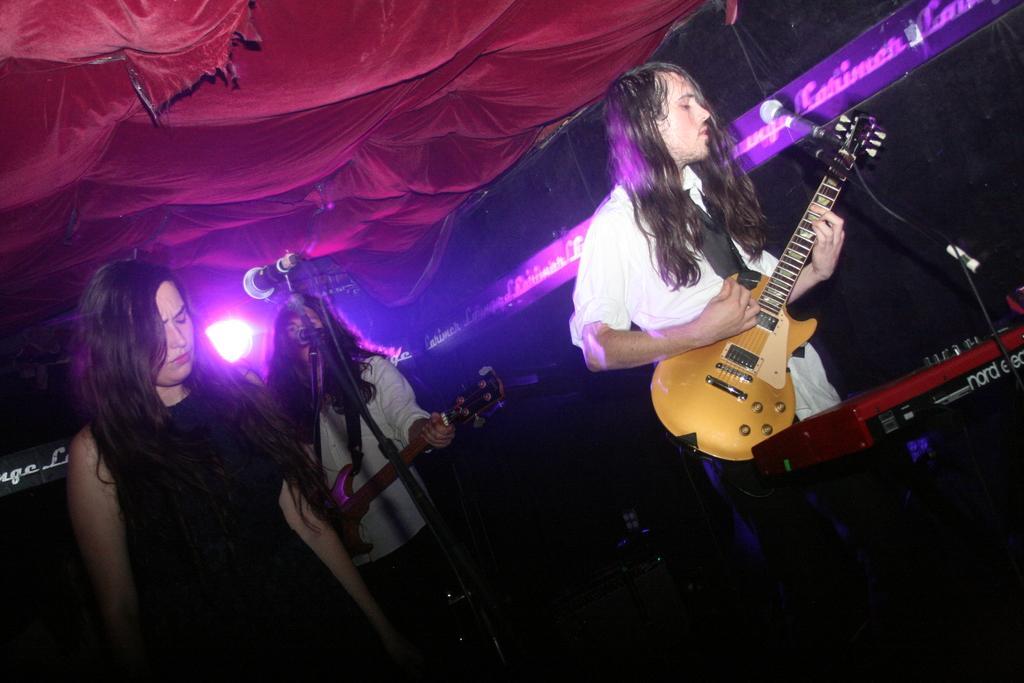In one or two sentences, can you explain what this image depicts? In the picture there is a woman in front of mic. There is a guy with long hair playing a guitar and, in background there is another guy playing guitar. There is purple light in the total background and above its a cloth. 